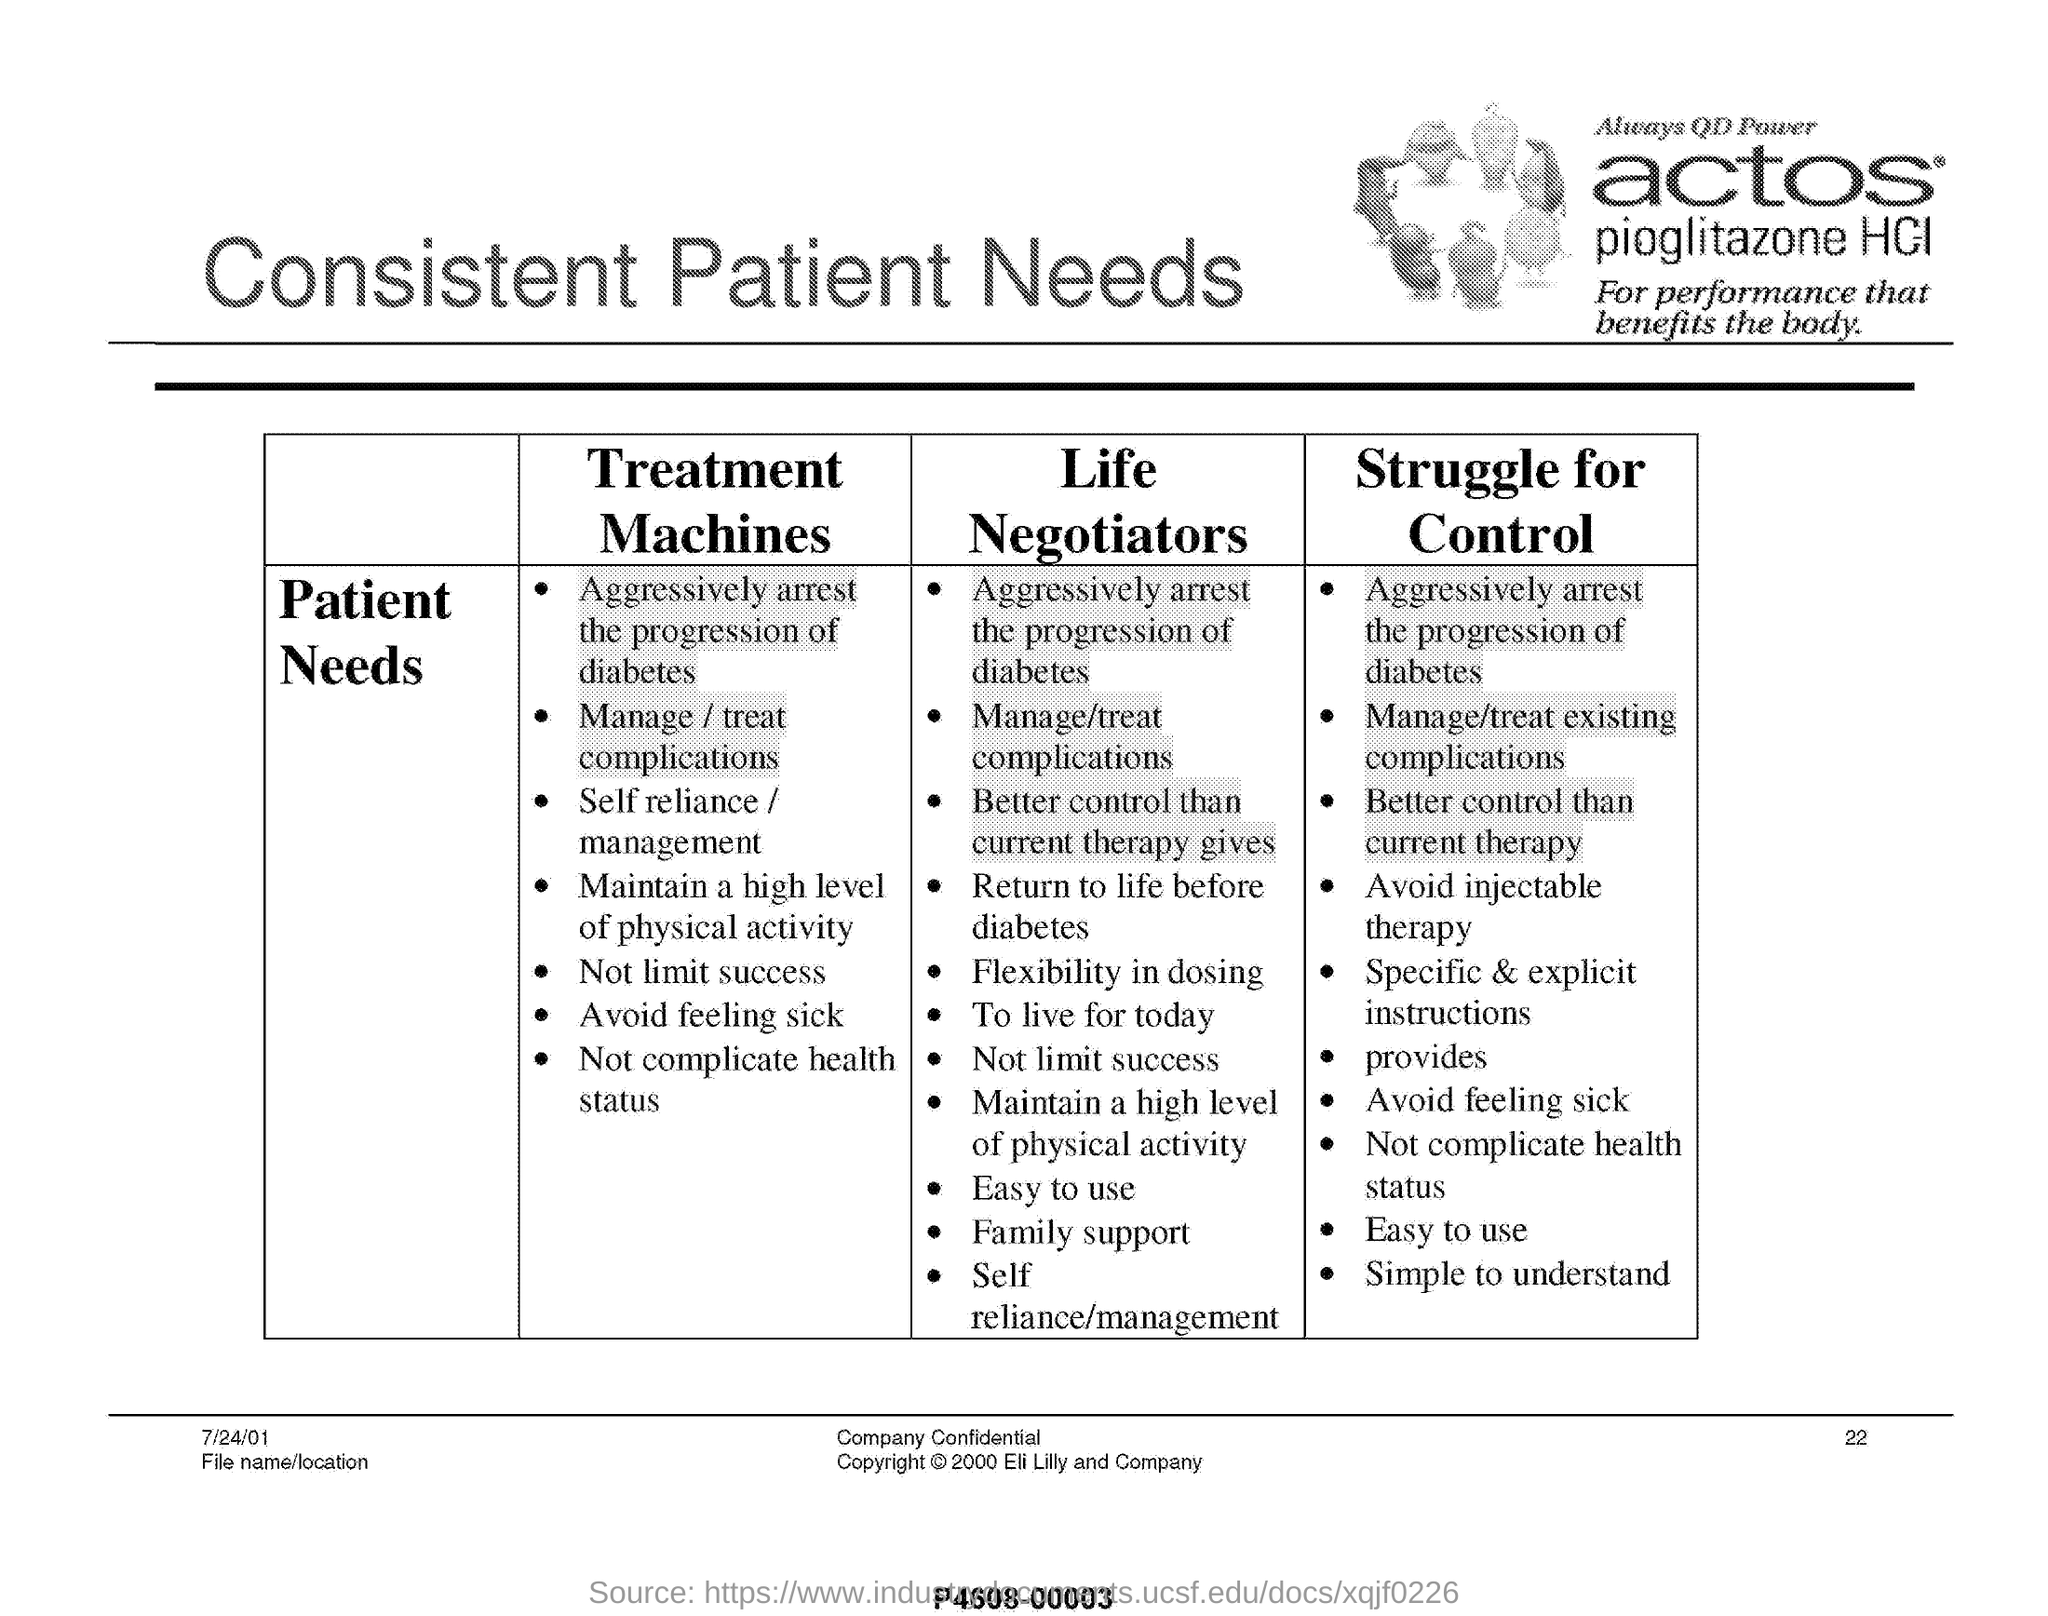Give some essential details in this illustration. The date mentioned in this document is July 24th, 2001. The page number mentioned in this document is 22. 